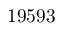Convert formula to latex. <formula><loc_0><loc_0><loc_500><loc_500>1 9 5 9 3</formula> 